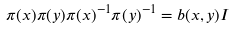Convert formula to latex. <formula><loc_0><loc_0><loc_500><loc_500>\pi ( x ) \pi ( y ) \pi ( x ) ^ { - 1 } \pi ( y ) ^ { - 1 } = b ( x , y ) I</formula> 